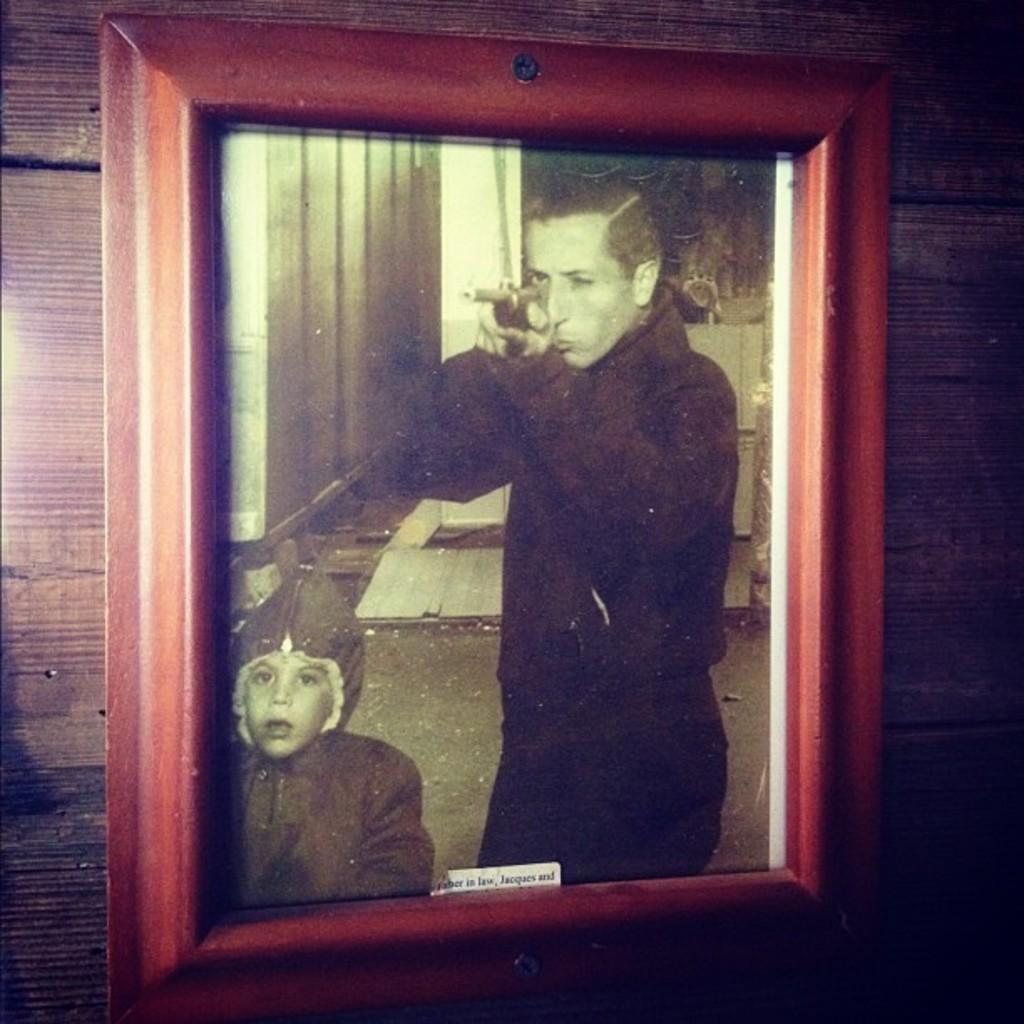How would you summarize this image in a sentence or two? In this image, we can see a photo frame with sticker on the wooden wall. In this picture, we can see a person is holding a gun. Here we can see a kid. 